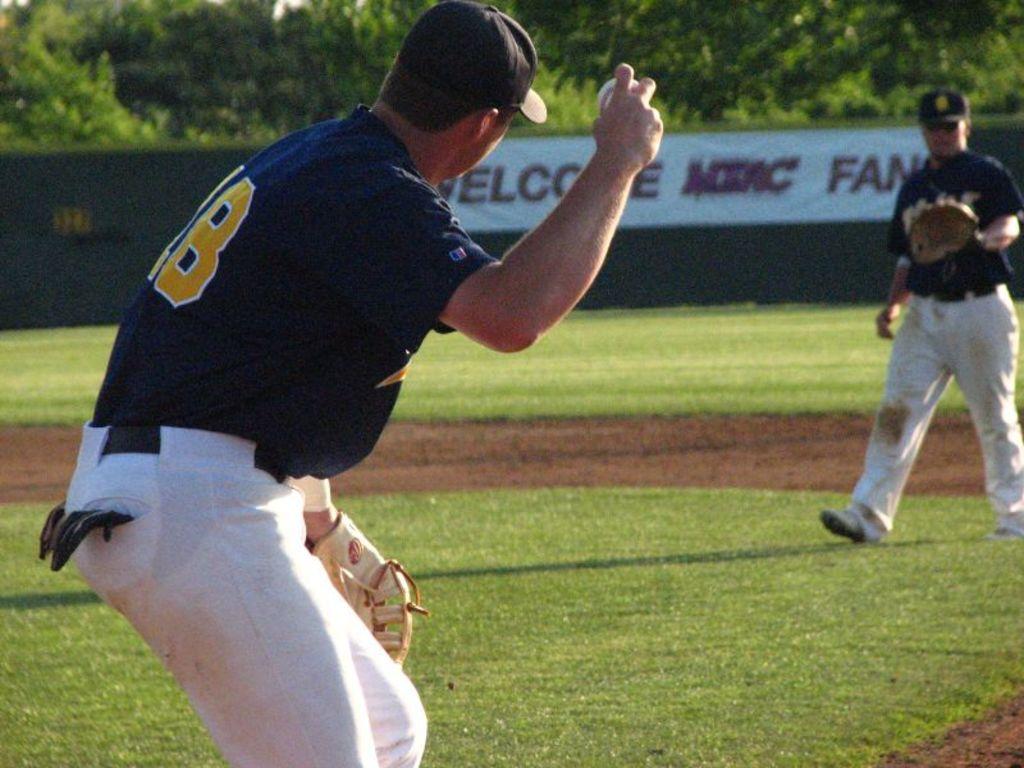Who is a sponsor of the ball park?
Your answer should be compact. Unanswerable. What is the last word on the sign?
Your answer should be very brief. Fan. 